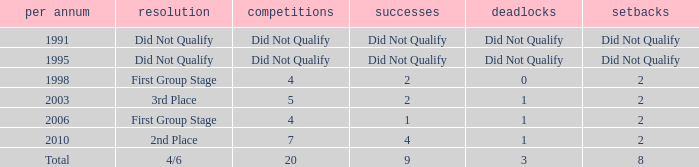What was the result for the team with 3 draws? 4/6. 